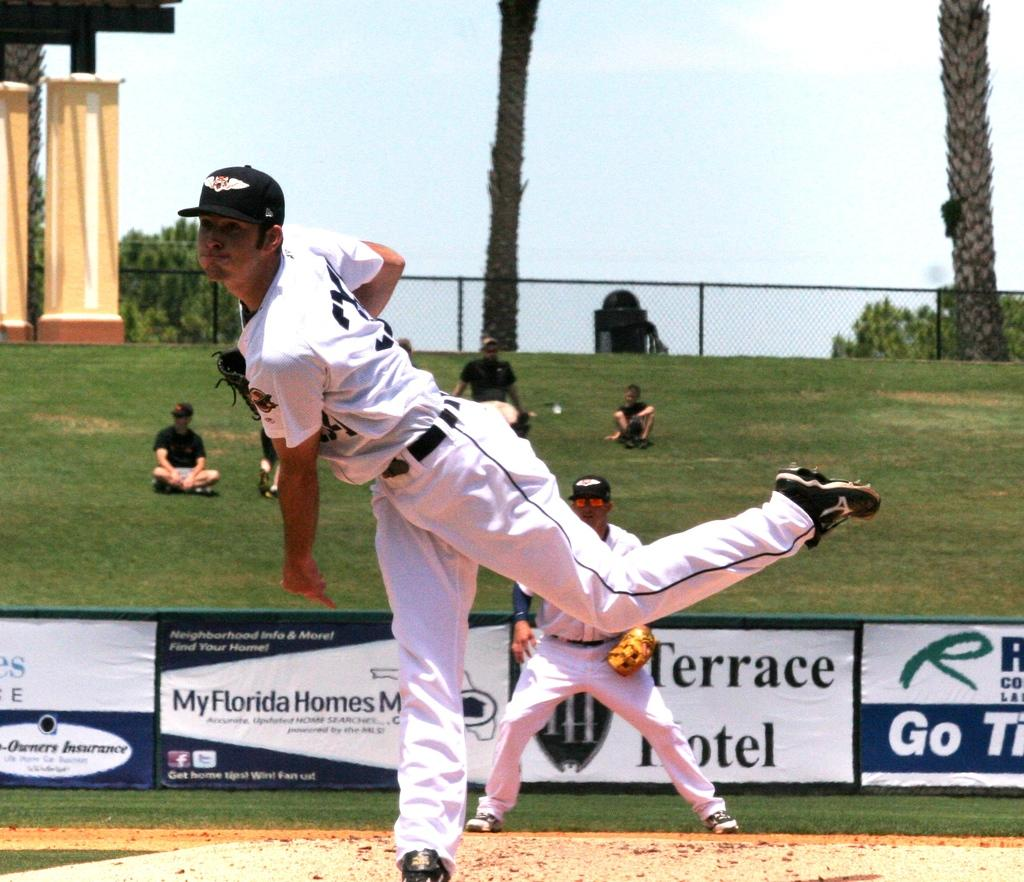<image>
Summarize the visual content of the image. a baseball player throwing a ball with a terrace hotel ad in the background 